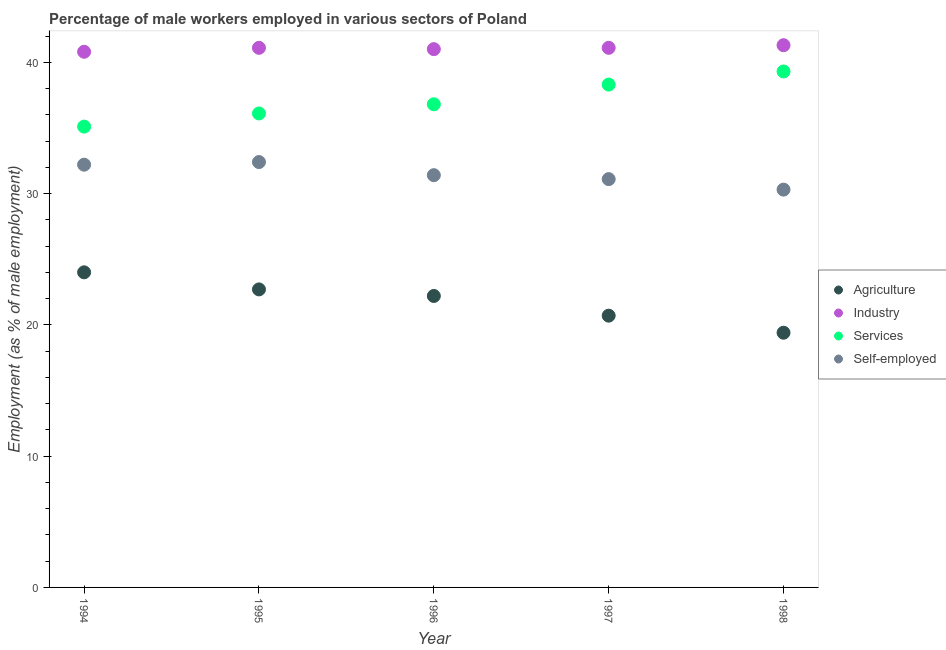How many different coloured dotlines are there?
Give a very brief answer. 4. What is the percentage of male workers in agriculture in 1995?
Make the answer very short. 22.7. Across all years, what is the maximum percentage of male workers in services?
Your response must be concise. 39.3. Across all years, what is the minimum percentage of male workers in industry?
Give a very brief answer. 40.8. In which year was the percentage of male workers in agriculture maximum?
Make the answer very short. 1994. In which year was the percentage of male workers in industry minimum?
Your answer should be very brief. 1994. What is the total percentage of male workers in industry in the graph?
Make the answer very short. 205.3. What is the difference between the percentage of self employed male workers in 1994 and that in 1998?
Provide a succinct answer. 1.9. What is the difference between the percentage of self employed male workers in 1996 and the percentage of male workers in industry in 1995?
Offer a very short reply. -9.7. What is the average percentage of male workers in industry per year?
Offer a terse response. 41.06. In the year 1998, what is the difference between the percentage of self employed male workers and percentage of male workers in agriculture?
Provide a short and direct response. 10.9. In how many years, is the percentage of male workers in services greater than 22 %?
Keep it short and to the point. 5. What is the ratio of the percentage of male workers in services in 1996 to that in 1998?
Make the answer very short. 0.94. What is the difference between the highest and the second highest percentage of self employed male workers?
Give a very brief answer. 0.2. What is the difference between the highest and the lowest percentage of male workers in agriculture?
Give a very brief answer. 4.6. In how many years, is the percentage of male workers in agriculture greater than the average percentage of male workers in agriculture taken over all years?
Make the answer very short. 3. Is the percentage of male workers in services strictly less than the percentage of self employed male workers over the years?
Keep it short and to the point. No. How many dotlines are there?
Offer a terse response. 4. How many years are there in the graph?
Your answer should be compact. 5. Are the values on the major ticks of Y-axis written in scientific E-notation?
Your answer should be very brief. No. What is the title of the graph?
Offer a very short reply. Percentage of male workers employed in various sectors of Poland. Does "Forest" appear as one of the legend labels in the graph?
Your response must be concise. No. What is the label or title of the X-axis?
Your answer should be very brief. Year. What is the label or title of the Y-axis?
Your answer should be compact. Employment (as % of male employment). What is the Employment (as % of male employment) in Industry in 1994?
Keep it short and to the point. 40.8. What is the Employment (as % of male employment) of Services in 1994?
Your answer should be compact. 35.1. What is the Employment (as % of male employment) in Self-employed in 1994?
Offer a very short reply. 32.2. What is the Employment (as % of male employment) in Agriculture in 1995?
Provide a succinct answer. 22.7. What is the Employment (as % of male employment) in Industry in 1995?
Your answer should be very brief. 41.1. What is the Employment (as % of male employment) in Services in 1995?
Give a very brief answer. 36.1. What is the Employment (as % of male employment) of Self-employed in 1995?
Give a very brief answer. 32.4. What is the Employment (as % of male employment) of Agriculture in 1996?
Keep it short and to the point. 22.2. What is the Employment (as % of male employment) of Services in 1996?
Provide a short and direct response. 36.8. What is the Employment (as % of male employment) in Self-employed in 1996?
Ensure brevity in your answer.  31.4. What is the Employment (as % of male employment) in Agriculture in 1997?
Provide a succinct answer. 20.7. What is the Employment (as % of male employment) in Industry in 1997?
Give a very brief answer. 41.1. What is the Employment (as % of male employment) of Services in 1997?
Your answer should be very brief. 38.3. What is the Employment (as % of male employment) of Self-employed in 1997?
Give a very brief answer. 31.1. What is the Employment (as % of male employment) in Agriculture in 1998?
Ensure brevity in your answer.  19.4. What is the Employment (as % of male employment) of Industry in 1998?
Your answer should be very brief. 41.3. What is the Employment (as % of male employment) in Services in 1998?
Offer a terse response. 39.3. What is the Employment (as % of male employment) of Self-employed in 1998?
Your response must be concise. 30.3. Across all years, what is the maximum Employment (as % of male employment) in Industry?
Provide a succinct answer. 41.3. Across all years, what is the maximum Employment (as % of male employment) of Services?
Ensure brevity in your answer.  39.3. Across all years, what is the maximum Employment (as % of male employment) in Self-employed?
Your answer should be compact. 32.4. Across all years, what is the minimum Employment (as % of male employment) of Agriculture?
Your answer should be very brief. 19.4. Across all years, what is the minimum Employment (as % of male employment) of Industry?
Make the answer very short. 40.8. Across all years, what is the minimum Employment (as % of male employment) of Services?
Keep it short and to the point. 35.1. Across all years, what is the minimum Employment (as % of male employment) of Self-employed?
Keep it short and to the point. 30.3. What is the total Employment (as % of male employment) of Agriculture in the graph?
Give a very brief answer. 109. What is the total Employment (as % of male employment) in Industry in the graph?
Ensure brevity in your answer.  205.3. What is the total Employment (as % of male employment) of Services in the graph?
Give a very brief answer. 185.6. What is the total Employment (as % of male employment) of Self-employed in the graph?
Keep it short and to the point. 157.4. What is the difference between the Employment (as % of male employment) in Services in 1994 and that in 1995?
Give a very brief answer. -1. What is the difference between the Employment (as % of male employment) of Industry in 1994 and that in 1996?
Provide a succinct answer. -0.2. What is the difference between the Employment (as % of male employment) in Self-employed in 1994 and that in 1996?
Keep it short and to the point. 0.8. What is the difference between the Employment (as % of male employment) in Agriculture in 1994 and that in 1997?
Keep it short and to the point. 3.3. What is the difference between the Employment (as % of male employment) in Industry in 1994 and that in 1997?
Make the answer very short. -0.3. What is the difference between the Employment (as % of male employment) in Services in 1994 and that in 1997?
Make the answer very short. -3.2. What is the difference between the Employment (as % of male employment) of Services in 1994 and that in 1998?
Your answer should be compact. -4.2. What is the difference between the Employment (as % of male employment) in Self-employed in 1994 and that in 1998?
Provide a short and direct response. 1.9. What is the difference between the Employment (as % of male employment) of Agriculture in 1995 and that in 1996?
Ensure brevity in your answer.  0.5. What is the difference between the Employment (as % of male employment) in Agriculture in 1995 and that in 1997?
Offer a very short reply. 2. What is the difference between the Employment (as % of male employment) of Services in 1995 and that in 1997?
Give a very brief answer. -2.2. What is the difference between the Employment (as % of male employment) in Industry in 1995 and that in 1998?
Make the answer very short. -0.2. What is the difference between the Employment (as % of male employment) of Services in 1995 and that in 1998?
Keep it short and to the point. -3.2. What is the difference between the Employment (as % of male employment) of Self-employed in 1995 and that in 1998?
Make the answer very short. 2.1. What is the difference between the Employment (as % of male employment) of Agriculture in 1996 and that in 1998?
Your answer should be compact. 2.8. What is the difference between the Employment (as % of male employment) of Industry in 1996 and that in 1998?
Ensure brevity in your answer.  -0.3. What is the difference between the Employment (as % of male employment) in Services in 1996 and that in 1998?
Provide a short and direct response. -2.5. What is the difference between the Employment (as % of male employment) in Agriculture in 1997 and that in 1998?
Your answer should be compact. 1.3. What is the difference between the Employment (as % of male employment) in Industry in 1997 and that in 1998?
Offer a very short reply. -0.2. What is the difference between the Employment (as % of male employment) in Services in 1997 and that in 1998?
Offer a very short reply. -1. What is the difference between the Employment (as % of male employment) of Self-employed in 1997 and that in 1998?
Ensure brevity in your answer.  0.8. What is the difference between the Employment (as % of male employment) of Agriculture in 1994 and the Employment (as % of male employment) of Industry in 1995?
Provide a short and direct response. -17.1. What is the difference between the Employment (as % of male employment) of Industry in 1994 and the Employment (as % of male employment) of Self-employed in 1995?
Make the answer very short. 8.4. What is the difference between the Employment (as % of male employment) in Agriculture in 1994 and the Employment (as % of male employment) in Industry in 1996?
Provide a short and direct response. -17. What is the difference between the Employment (as % of male employment) of Agriculture in 1994 and the Employment (as % of male employment) of Industry in 1997?
Keep it short and to the point. -17.1. What is the difference between the Employment (as % of male employment) of Agriculture in 1994 and the Employment (as % of male employment) of Services in 1997?
Ensure brevity in your answer.  -14.3. What is the difference between the Employment (as % of male employment) of Industry in 1994 and the Employment (as % of male employment) of Services in 1997?
Provide a succinct answer. 2.5. What is the difference between the Employment (as % of male employment) of Services in 1994 and the Employment (as % of male employment) of Self-employed in 1997?
Your answer should be very brief. 4. What is the difference between the Employment (as % of male employment) of Agriculture in 1994 and the Employment (as % of male employment) of Industry in 1998?
Ensure brevity in your answer.  -17.3. What is the difference between the Employment (as % of male employment) in Agriculture in 1994 and the Employment (as % of male employment) in Services in 1998?
Give a very brief answer. -15.3. What is the difference between the Employment (as % of male employment) of Agriculture in 1994 and the Employment (as % of male employment) of Self-employed in 1998?
Keep it short and to the point. -6.3. What is the difference between the Employment (as % of male employment) of Industry in 1994 and the Employment (as % of male employment) of Services in 1998?
Offer a very short reply. 1.5. What is the difference between the Employment (as % of male employment) in Industry in 1994 and the Employment (as % of male employment) in Self-employed in 1998?
Your answer should be very brief. 10.5. What is the difference between the Employment (as % of male employment) of Services in 1994 and the Employment (as % of male employment) of Self-employed in 1998?
Make the answer very short. 4.8. What is the difference between the Employment (as % of male employment) of Agriculture in 1995 and the Employment (as % of male employment) of Industry in 1996?
Offer a terse response. -18.3. What is the difference between the Employment (as % of male employment) in Agriculture in 1995 and the Employment (as % of male employment) in Services in 1996?
Your response must be concise. -14.1. What is the difference between the Employment (as % of male employment) in Industry in 1995 and the Employment (as % of male employment) in Services in 1996?
Your answer should be compact. 4.3. What is the difference between the Employment (as % of male employment) in Services in 1995 and the Employment (as % of male employment) in Self-employed in 1996?
Your answer should be compact. 4.7. What is the difference between the Employment (as % of male employment) in Agriculture in 1995 and the Employment (as % of male employment) in Industry in 1997?
Give a very brief answer. -18.4. What is the difference between the Employment (as % of male employment) of Agriculture in 1995 and the Employment (as % of male employment) of Services in 1997?
Keep it short and to the point. -15.6. What is the difference between the Employment (as % of male employment) of Industry in 1995 and the Employment (as % of male employment) of Services in 1997?
Keep it short and to the point. 2.8. What is the difference between the Employment (as % of male employment) in Services in 1995 and the Employment (as % of male employment) in Self-employed in 1997?
Make the answer very short. 5. What is the difference between the Employment (as % of male employment) in Agriculture in 1995 and the Employment (as % of male employment) in Industry in 1998?
Your answer should be very brief. -18.6. What is the difference between the Employment (as % of male employment) in Agriculture in 1995 and the Employment (as % of male employment) in Services in 1998?
Make the answer very short. -16.6. What is the difference between the Employment (as % of male employment) in Industry in 1995 and the Employment (as % of male employment) in Services in 1998?
Your answer should be compact. 1.8. What is the difference between the Employment (as % of male employment) in Industry in 1995 and the Employment (as % of male employment) in Self-employed in 1998?
Make the answer very short. 10.8. What is the difference between the Employment (as % of male employment) in Agriculture in 1996 and the Employment (as % of male employment) in Industry in 1997?
Provide a short and direct response. -18.9. What is the difference between the Employment (as % of male employment) of Agriculture in 1996 and the Employment (as % of male employment) of Services in 1997?
Make the answer very short. -16.1. What is the difference between the Employment (as % of male employment) of Agriculture in 1996 and the Employment (as % of male employment) of Self-employed in 1997?
Your answer should be compact. -8.9. What is the difference between the Employment (as % of male employment) of Industry in 1996 and the Employment (as % of male employment) of Services in 1997?
Your answer should be very brief. 2.7. What is the difference between the Employment (as % of male employment) of Industry in 1996 and the Employment (as % of male employment) of Self-employed in 1997?
Ensure brevity in your answer.  9.9. What is the difference between the Employment (as % of male employment) of Agriculture in 1996 and the Employment (as % of male employment) of Industry in 1998?
Offer a terse response. -19.1. What is the difference between the Employment (as % of male employment) in Agriculture in 1996 and the Employment (as % of male employment) in Services in 1998?
Make the answer very short. -17.1. What is the difference between the Employment (as % of male employment) in Agriculture in 1996 and the Employment (as % of male employment) in Self-employed in 1998?
Offer a very short reply. -8.1. What is the difference between the Employment (as % of male employment) of Industry in 1996 and the Employment (as % of male employment) of Services in 1998?
Provide a succinct answer. 1.7. What is the difference between the Employment (as % of male employment) in Industry in 1996 and the Employment (as % of male employment) in Self-employed in 1998?
Offer a terse response. 10.7. What is the difference between the Employment (as % of male employment) in Agriculture in 1997 and the Employment (as % of male employment) in Industry in 1998?
Ensure brevity in your answer.  -20.6. What is the difference between the Employment (as % of male employment) of Agriculture in 1997 and the Employment (as % of male employment) of Services in 1998?
Give a very brief answer. -18.6. What is the difference between the Employment (as % of male employment) of Industry in 1997 and the Employment (as % of male employment) of Services in 1998?
Ensure brevity in your answer.  1.8. What is the difference between the Employment (as % of male employment) in Industry in 1997 and the Employment (as % of male employment) in Self-employed in 1998?
Your response must be concise. 10.8. What is the difference between the Employment (as % of male employment) in Services in 1997 and the Employment (as % of male employment) in Self-employed in 1998?
Offer a very short reply. 8. What is the average Employment (as % of male employment) in Agriculture per year?
Provide a short and direct response. 21.8. What is the average Employment (as % of male employment) of Industry per year?
Keep it short and to the point. 41.06. What is the average Employment (as % of male employment) in Services per year?
Keep it short and to the point. 37.12. What is the average Employment (as % of male employment) of Self-employed per year?
Make the answer very short. 31.48. In the year 1994, what is the difference between the Employment (as % of male employment) in Agriculture and Employment (as % of male employment) in Industry?
Provide a short and direct response. -16.8. In the year 1994, what is the difference between the Employment (as % of male employment) in Industry and Employment (as % of male employment) in Services?
Provide a succinct answer. 5.7. In the year 1994, what is the difference between the Employment (as % of male employment) in Industry and Employment (as % of male employment) in Self-employed?
Your response must be concise. 8.6. In the year 1994, what is the difference between the Employment (as % of male employment) of Services and Employment (as % of male employment) of Self-employed?
Keep it short and to the point. 2.9. In the year 1995, what is the difference between the Employment (as % of male employment) of Agriculture and Employment (as % of male employment) of Industry?
Ensure brevity in your answer.  -18.4. In the year 1995, what is the difference between the Employment (as % of male employment) in Services and Employment (as % of male employment) in Self-employed?
Offer a very short reply. 3.7. In the year 1996, what is the difference between the Employment (as % of male employment) of Agriculture and Employment (as % of male employment) of Industry?
Provide a short and direct response. -18.8. In the year 1996, what is the difference between the Employment (as % of male employment) in Agriculture and Employment (as % of male employment) in Services?
Your answer should be very brief. -14.6. In the year 1996, what is the difference between the Employment (as % of male employment) of Industry and Employment (as % of male employment) of Self-employed?
Offer a very short reply. 9.6. In the year 1997, what is the difference between the Employment (as % of male employment) of Agriculture and Employment (as % of male employment) of Industry?
Offer a terse response. -20.4. In the year 1997, what is the difference between the Employment (as % of male employment) in Agriculture and Employment (as % of male employment) in Services?
Ensure brevity in your answer.  -17.6. In the year 1997, what is the difference between the Employment (as % of male employment) in Agriculture and Employment (as % of male employment) in Self-employed?
Provide a short and direct response. -10.4. In the year 1997, what is the difference between the Employment (as % of male employment) in Industry and Employment (as % of male employment) in Services?
Your answer should be compact. 2.8. In the year 1998, what is the difference between the Employment (as % of male employment) in Agriculture and Employment (as % of male employment) in Industry?
Give a very brief answer. -21.9. In the year 1998, what is the difference between the Employment (as % of male employment) of Agriculture and Employment (as % of male employment) of Services?
Keep it short and to the point. -19.9. In the year 1998, what is the difference between the Employment (as % of male employment) of Industry and Employment (as % of male employment) of Self-employed?
Offer a very short reply. 11. In the year 1998, what is the difference between the Employment (as % of male employment) in Services and Employment (as % of male employment) in Self-employed?
Provide a succinct answer. 9. What is the ratio of the Employment (as % of male employment) of Agriculture in 1994 to that in 1995?
Provide a succinct answer. 1.06. What is the ratio of the Employment (as % of male employment) of Industry in 1994 to that in 1995?
Offer a terse response. 0.99. What is the ratio of the Employment (as % of male employment) of Services in 1994 to that in 1995?
Offer a very short reply. 0.97. What is the ratio of the Employment (as % of male employment) in Self-employed in 1994 to that in 1995?
Provide a succinct answer. 0.99. What is the ratio of the Employment (as % of male employment) in Agriculture in 1994 to that in 1996?
Make the answer very short. 1.08. What is the ratio of the Employment (as % of male employment) of Industry in 1994 to that in 1996?
Provide a succinct answer. 1. What is the ratio of the Employment (as % of male employment) of Services in 1994 to that in 1996?
Offer a very short reply. 0.95. What is the ratio of the Employment (as % of male employment) in Self-employed in 1994 to that in 1996?
Your response must be concise. 1.03. What is the ratio of the Employment (as % of male employment) in Agriculture in 1994 to that in 1997?
Offer a terse response. 1.16. What is the ratio of the Employment (as % of male employment) of Services in 1994 to that in 1997?
Your response must be concise. 0.92. What is the ratio of the Employment (as % of male employment) in Self-employed in 1994 to that in 1997?
Your response must be concise. 1.04. What is the ratio of the Employment (as % of male employment) of Agriculture in 1994 to that in 1998?
Give a very brief answer. 1.24. What is the ratio of the Employment (as % of male employment) in Industry in 1994 to that in 1998?
Your response must be concise. 0.99. What is the ratio of the Employment (as % of male employment) of Services in 1994 to that in 1998?
Provide a succinct answer. 0.89. What is the ratio of the Employment (as % of male employment) in Self-employed in 1994 to that in 1998?
Offer a very short reply. 1.06. What is the ratio of the Employment (as % of male employment) in Agriculture in 1995 to that in 1996?
Offer a very short reply. 1.02. What is the ratio of the Employment (as % of male employment) of Industry in 1995 to that in 1996?
Your response must be concise. 1. What is the ratio of the Employment (as % of male employment) of Self-employed in 1995 to that in 1996?
Ensure brevity in your answer.  1.03. What is the ratio of the Employment (as % of male employment) in Agriculture in 1995 to that in 1997?
Ensure brevity in your answer.  1.1. What is the ratio of the Employment (as % of male employment) in Services in 1995 to that in 1997?
Make the answer very short. 0.94. What is the ratio of the Employment (as % of male employment) of Self-employed in 1995 to that in 1997?
Offer a very short reply. 1.04. What is the ratio of the Employment (as % of male employment) in Agriculture in 1995 to that in 1998?
Your answer should be compact. 1.17. What is the ratio of the Employment (as % of male employment) in Services in 1995 to that in 1998?
Make the answer very short. 0.92. What is the ratio of the Employment (as % of male employment) in Self-employed in 1995 to that in 1998?
Offer a terse response. 1.07. What is the ratio of the Employment (as % of male employment) in Agriculture in 1996 to that in 1997?
Your response must be concise. 1.07. What is the ratio of the Employment (as % of male employment) of Services in 1996 to that in 1997?
Your response must be concise. 0.96. What is the ratio of the Employment (as % of male employment) in Self-employed in 1996 to that in 1997?
Your answer should be compact. 1.01. What is the ratio of the Employment (as % of male employment) of Agriculture in 1996 to that in 1998?
Provide a succinct answer. 1.14. What is the ratio of the Employment (as % of male employment) of Industry in 1996 to that in 1998?
Give a very brief answer. 0.99. What is the ratio of the Employment (as % of male employment) of Services in 1996 to that in 1998?
Your response must be concise. 0.94. What is the ratio of the Employment (as % of male employment) in Self-employed in 1996 to that in 1998?
Give a very brief answer. 1.04. What is the ratio of the Employment (as % of male employment) in Agriculture in 1997 to that in 1998?
Your answer should be compact. 1.07. What is the ratio of the Employment (as % of male employment) in Services in 1997 to that in 1998?
Provide a short and direct response. 0.97. What is the ratio of the Employment (as % of male employment) in Self-employed in 1997 to that in 1998?
Provide a succinct answer. 1.03. What is the difference between the highest and the second highest Employment (as % of male employment) in Industry?
Give a very brief answer. 0.2. What is the difference between the highest and the second highest Employment (as % of male employment) in Self-employed?
Make the answer very short. 0.2. What is the difference between the highest and the lowest Employment (as % of male employment) of Agriculture?
Keep it short and to the point. 4.6. 